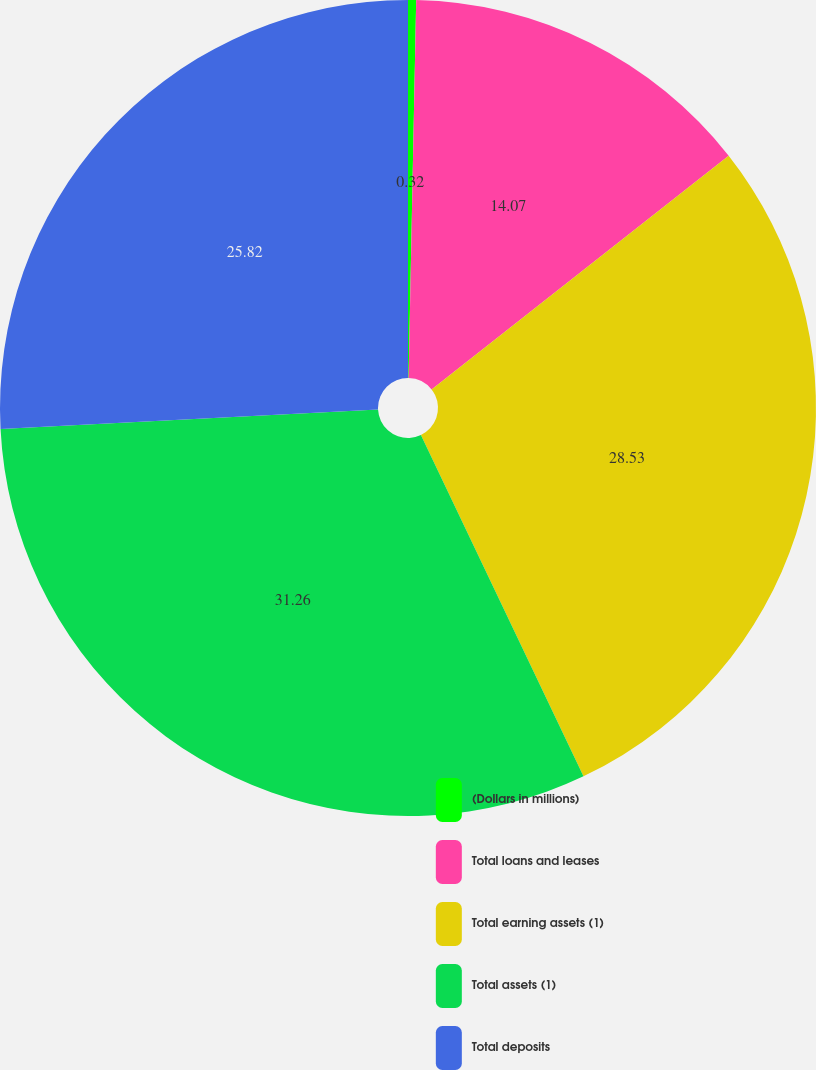<chart> <loc_0><loc_0><loc_500><loc_500><pie_chart><fcel>(Dollars in millions)<fcel>Total loans and leases<fcel>Total earning assets (1)<fcel>Total assets (1)<fcel>Total deposits<nl><fcel>0.32%<fcel>14.07%<fcel>28.53%<fcel>31.25%<fcel>25.82%<nl></chart> 